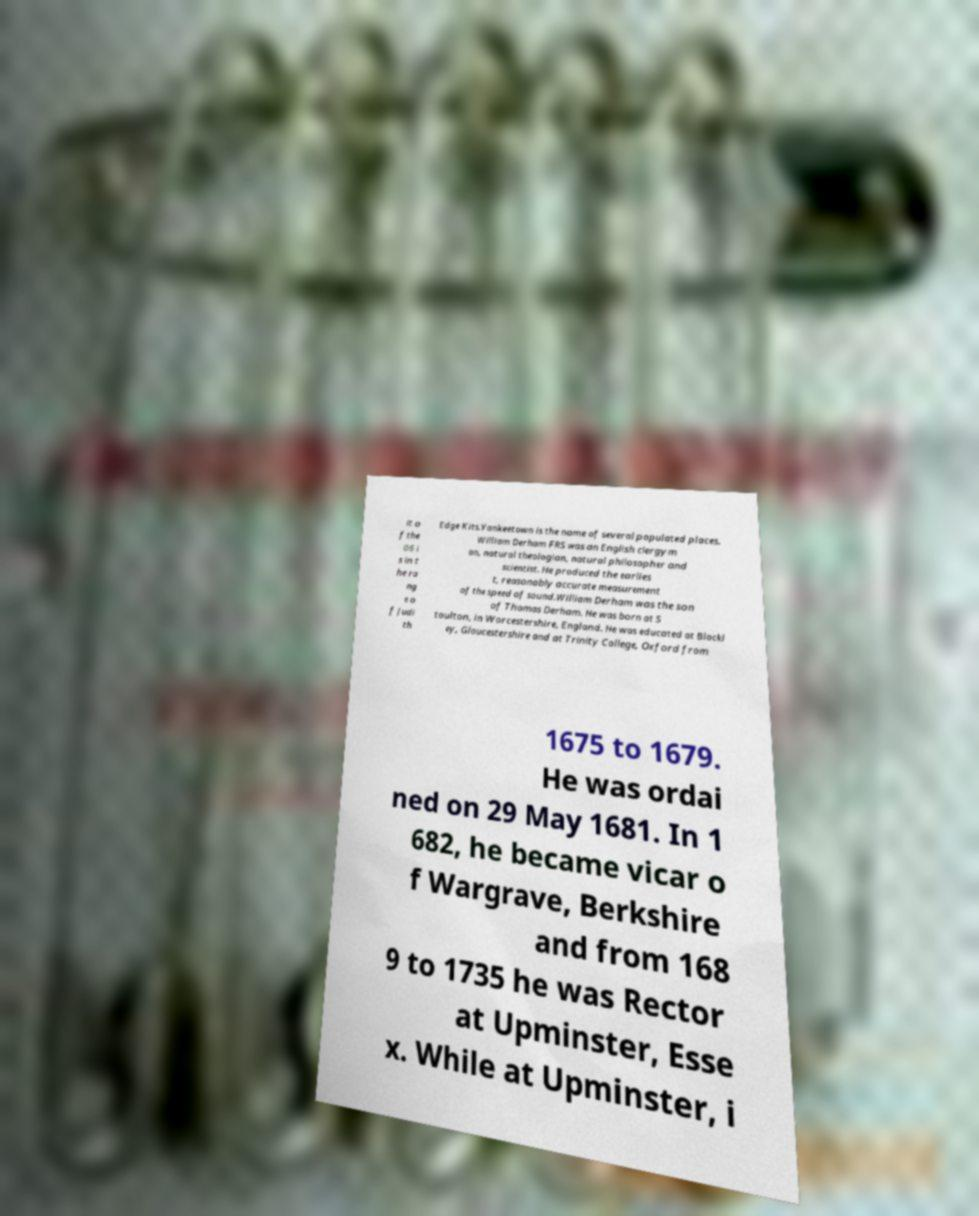Can you read and provide the text displayed in the image?This photo seems to have some interesting text. Can you extract and type it out for me? it o f the 06 i s in t he ra ng e o f Judi th Edge Kits.Yankeetown is the name of several populated places. William Derham FRS was an English clergym an, natural theologian, natural philosopher and scientist. He produced the earlies t, reasonably accurate measurement of the speed of sound.William Derham was the son of Thomas Derham. He was born at S toulton, in Worcestershire, England. He was educated at Blockl ey, Gloucestershire and at Trinity College, Oxford from 1675 to 1679. He was ordai ned on 29 May 1681. In 1 682, he became vicar o f Wargrave, Berkshire and from 168 9 to 1735 he was Rector at Upminster, Esse x. While at Upminster, i 